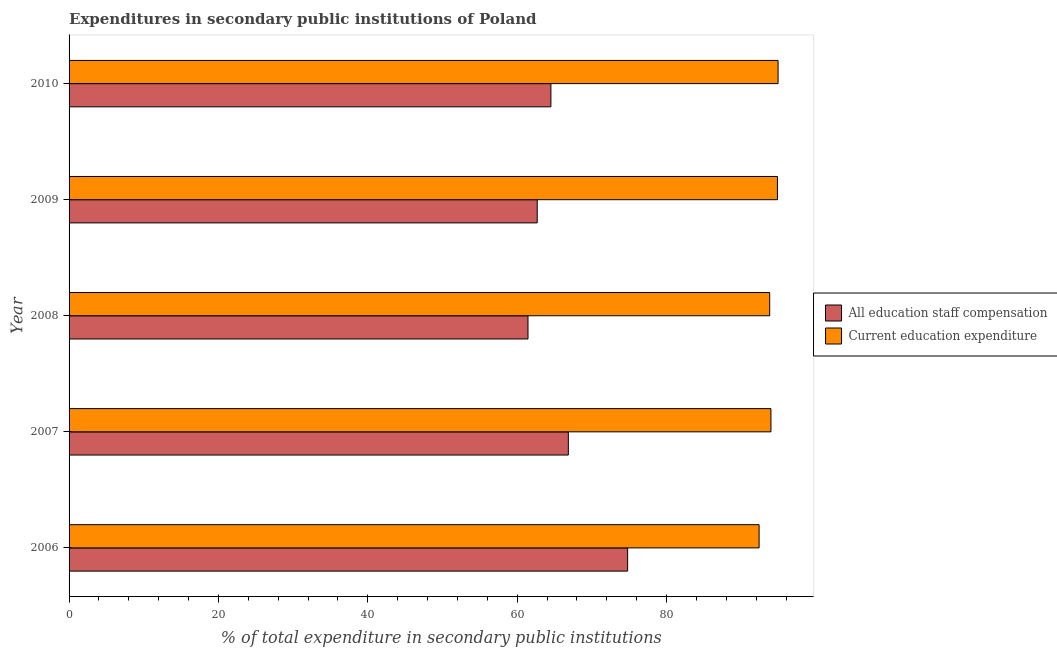Are the number of bars per tick equal to the number of legend labels?
Your answer should be compact. Yes. Are the number of bars on each tick of the Y-axis equal?
Make the answer very short. Yes. How many bars are there on the 3rd tick from the bottom?
Provide a short and direct response. 2. In how many cases, is the number of bars for a given year not equal to the number of legend labels?
Your answer should be very brief. 0. What is the expenditure in staff compensation in 2009?
Your answer should be very brief. 62.69. Across all years, what is the maximum expenditure in staff compensation?
Ensure brevity in your answer.  74.79. Across all years, what is the minimum expenditure in education?
Provide a short and direct response. 92.4. In which year was the expenditure in education maximum?
Provide a succinct answer. 2010. What is the total expenditure in education in the graph?
Offer a very short reply. 469.98. What is the difference between the expenditure in staff compensation in 2006 and that in 2010?
Offer a terse response. 10.27. What is the difference between the expenditure in education in 2008 and the expenditure in staff compensation in 2010?
Provide a succinct answer. 29.3. What is the average expenditure in staff compensation per year?
Keep it short and to the point. 66.06. In the year 2007, what is the difference between the expenditure in staff compensation and expenditure in education?
Your answer should be very brief. -27.13. In how many years, is the expenditure in staff compensation greater than 36 %?
Keep it short and to the point. 5. Is the expenditure in staff compensation in 2006 less than that in 2007?
Your response must be concise. No. What is the difference between the highest and the second highest expenditure in staff compensation?
Your answer should be very brief. 7.94. What is the difference between the highest and the lowest expenditure in education?
Your response must be concise. 2.54. What does the 2nd bar from the top in 2010 represents?
Provide a short and direct response. All education staff compensation. What does the 2nd bar from the bottom in 2008 represents?
Your response must be concise. Current education expenditure. How many bars are there?
Your response must be concise. 10. How many years are there in the graph?
Your answer should be very brief. 5. Are the values on the major ticks of X-axis written in scientific E-notation?
Give a very brief answer. No. Does the graph contain grids?
Your answer should be very brief. No. How many legend labels are there?
Provide a short and direct response. 2. What is the title of the graph?
Your answer should be very brief. Expenditures in secondary public institutions of Poland. Does "Mobile cellular" appear as one of the legend labels in the graph?
Make the answer very short. No. What is the label or title of the X-axis?
Offer a very short reply. % of total expenditure in secondary public institutions. What is the % of total expenditure in secondary public institutions of All education staff compensation in 2006?
Provide a succinct answer. 74.79. What is the % of total expenditure in secondary public institutions in Current education expenditure in 2006?
Provide a succinct answer. 92.4. What is the % of total expenditure in secondary public institutions in All education staff compensation in 2007?
Your answer should be very brief. 66.85. What is the % of total expenditure in secondary public institutions of Current education expenditure in 2007?
Offer a terse response. 93.98. What is the % of total expenditure in secondary public institutions of All education staff compensation in 2008?
Give a very brief answer. 61.45. What is the % of total expenditure in secondary public institutions in Current education expenditure in 2008?
Provide a succinct answer. 93.82. What is the % of total expenditure in secondary public institutions of All education staff compensation in 2009?
Offer a very short reply. 62.69. What is the % of total expenditure in secondary public institutions in Current education expenditure in 2009?
Your answer should be very brief. 94.85. What is the % of total expenditure in secondary public institutions of All education staff compensation in 2010?
Offer a terse response. 64.52. What is the % of total expenditure in secondary public institutions in Current education expenditure in 2010?
Keep it short and to the point. 94.94. Across all years, what is the maximum % of total expenditure in secondary public institutions in All education staff compensation?
Provide a short and direct response. 74.79. Across all years, what is the maximum % of total expenditure in secondary public institutions in Current education expenditure?
Provide a succinct answer. 94.94. Across all years, what is the minimum % of total expenditure in secondary public institutions of All education staff compensation?
Give a very brief answer. 61.45. Across all years, what is the minimum % of total expenditure in secondary public institutions of Current education expenditure?
Make the answer very short. 92.4. What is the total % of total expenditure in secondary public institutions of All education staff compensation in the graph?
Offer a very short reply. 330.3. What is the total % of total expenditure in secondary public institutions in Current education expenditure in the graph?
Your answer should be very brief. 469.98. What is the difference between the % of total expenditure in secondary public institutions of All education staff compensation in 2006 and that in 2007?
Your answer should be compact. 7.94. What is the difference between the % of total expenditure in secondary public institutions in Current education expenditure in 2006 and that in 2007?
Give a very brief answer. -1.58. What is the difference between the % of total expenditure in secondary public institutions in All education staff compensation in 2006 and that in 2008?
Ensure brevity in your answer.  13.34. What is the difference between the % of total expenditure in secondary public institutions in Current education expenditure in 2006 and that in 2008?
Offer a very short reply. -1.42. What is the difference between the % of total expenditure in secondary public institutions in All education staff compensation in 2006 and that in 2009?
Give a very brief answer. 12.1. What is the difference between the % of total expenditure in secondary public institutions of Current education expenditure in 2006 and that in 2009?
Your answer should be compact. -2.45. What is the difference between the % of total expenditure in secondary public institutions of All education staff compensation in 2006 and that in 2010?
Make the answer very short. 10.27. What is the difference between the % of total expenditure in secondary public institutions in Current education expenditure in 2006 and that in 2010?
Offer a very short reply. -2.54. What is the difference between the % of total expenditure in secondary public institutions of All education staff compensation in 2007 and that in 2008?
Provide a succinct answer. 5.4. What is the difference between the % of total expenditure in secondary public institutions in Current education expenditure in 2007 and that in 2008?
Keep it short and to the point. 0.17. What is the difference between the % of total expenditure in secondary public institutions in All education staff compensation in 2007 and that in 2009?
Provide a short and direct response. 4.17. What is the difference between the % of total expenditure in secondary public institutions of Current education expenditure in 2007 and that in 2009?
Provide a succinct answer. -0.87. What is the difference between the % of total expenditure in secondary public institutions of All education staff compensation in 2007 and that in 2010?
Give a very brief answer. 2.34. What is the difference between the % of total expenditure in secondary public institutions of Current education expenditure in 2007 and that in 2010?
Offer a terse response. -0.96. What is the difference between the % of total expenditure in secondary public institutions of All education staff compensation in 2008 and that in 2009?
Offer a terse response. -1.23. What is the difference between the % of total expenditure in secondary public institutions of Current education expenditure in 2008 and that in 2009?
Offer a terse response. -1.04. What is the difference between the % of total expenditure in secondary public institutions of All education staff compensation in 2008 and that in 2010?
Offer a very short reply. -3.07. What is the difference between the % of total expenditure in secondary public institutions of Current education expenditure in 2008 and that in 2010?
Ensure brevity in your answer.  -1.12. What is the difference between the % of total expenditure in secondary public institutions of All education staff compensation in 2009 and that in 2010?
Give a very brief answer. -1.83. What is the difference between the % of total expenditure in secondary public institutions in Current education expenditure in 2009 and that in 2010?
Make the answer very short. -0.08. What is the difference between the % of total expenditure in secondary public institutions of All education staff compensation in 2006 and the % of total expenditure in secondary public institutions of Current education expenditure in 2007?
Offer a terse response. -19.19. What is the difference between the % of total expenditure in secondary public institutions of All education staff compensation in 2006 and the % of total expenditure in secondary public institutions of Current education expenditure in 2008?
Give a very brief answer. -19.03. What is the difference between the % of total expenditure in secondary public institutions of All education staff compensation in 2006 and the % of total expenditure in secondary public institutions of Current education expenditure in 2009?
Ensure brevity in your answer.  -20.06. What is the difference between the % of total expenditure in secondary public institutions in All education staff compensation in 2006 and the % of total expenditure in secondary public institutions in Current education expenditure in 2010?
Provide a short and direct response. -20.15. What is the difference between the % of total expenditure in secondary public institutions in All education staff compensation in 2007 and the % of total expenditure in secondary public institutions in Current education expenditure in 2008?
Make the answer very short. -26.96. What is the difference between the % of total expenditure in secondary public institutions of All education staff compensation in 2007 and the % of total expenditure in secondary public institutions of Current education expenditure in 2009?
Offer a very short reply. -28. What is the difference between the % of total expenditure in secondary public institutions of All education staff compensation in 2007 and the % of total expenditure in secondary public institutions of Current education expenditure in 2010?
Ensure brevity in your answer.  -28.08. What is the difference between the % of total expenditure in secondary public institutions of All education staff compensation in 2008 and the % of total expenditure in secondary public institutions of Current education expenditure in 2009?
Make the answer very short. -33.4. What is the difference between the % of total expenditure in secondary public institutions in All education staff compensation in 2008 and the % of total expenditure in secondary public institutions in Current education expenditure in 2010?
Your answer should be very brief. -33.49. What is the difference between the % of total expenditure in secondary public institutions of All education staff compensation in 2009 and the % of total expenditure in secondary public institutions of Current education expenditure in 2010?
Make the answer very short. -32.25. What is the average % of total expenditure in secondary public institutions in All education staff compensation per year?
Offer a terse response. 66.06. What is the average % of total expenditure in secondary public institutions in Current education expenditure per year?
Provide a succinct answer. 94. In the year 2006, what is the difference between the % of total expenditure in secondary public institutions in All education staff compensation and % of total expenditure in secondary public institutions in Current education expenditure?
Give a very brief answer. -17.61. In the year 2007, what is the difference between the % of total expenditure in secondary public institutions in All education staff compensation and % of total expenditure in secondary public institutions in Current education expenditure?
Offer a terse response. -27.13. In the year 2008, what is the difference between the % of total expenditure in secondary public institutions of All education staff compensation and % of total expenditure in secondary public institutions of Current education expenditure?
Give a very brief answer. -32.37. In the year 2009, what is the difference between the % of total expenditure in secondary public institutions of All education staff compensation and % of total expenditure in secondary public institutions of Current education expenditure?
Offer a very short reply. -32.17. In the year 2010, what is the difference between the % of total expenditure in secondary public institutions in All education staff compensation and % of total expenditure in secondary public institutions in Current education expenditure?
Your response must be concise. -30.42. What is the ratio of the % of total expenditure in secondary public institutions in All education staff compensation in 2006 to that in 2007?
Ensure brevity in your answer.  1.12. What is the ratio of the % of total expenditure in secondary public institutions of Current education expenditure in 2006 to that in 2007?
Keep it short and to the point. 0.98. What is the ratio of the % of total expenditure in secondary public institutions of All education staff compensation in 2006 to that in 2008?
Give a very brief answer. 1.22. What is the ratio of the % of total expenditure in secondary public institutions of Current education expenditure in 2006 to that in 2008?
Your answer should be very brief. 0.98. What is the ratio of the % of total expenditure in secondary public institutions of All education staff compensation in 2006 to that in 2009?
Your answer should be very brief. 1.19. What is the ratio of the % of total expenditure in secondary public institutions of Current education expenditure in 2006 to that in 2009?
Your response must be concise. 0.97. What is the ratio of the % of total expenditure in secondary public institutions in All education staff compensation in 2006 to that in 2010?
Keep it short and to the point. 1.16. What is the ratio of the % of total expenditure in secondary public institutions of Current education expenditure in 2006 to that in 2010?
Offer a very short reply. 0.97. What is the ratio of the % of total expenditure in secondary public institutions in All education staff compensation in 2007 to that in 2008?
Give a very brief answer. 1.09. What is the ratio of the % of total expenditure in secondary public institutions of Current education expenditure in 2007 to that in 2008?
Offer a very short reply. 1. What is the ratio of the % of total expenditure in secondary public institutions of All education staff compensation in 2007 to that in 2009?
Your response must be concise. 1.07. What is the ratio of the % of total expenditure in secondary public institutions in Current education expenditure in 2007 to that in 2009?
Provide a short and direct response. 0.99. What is the ratio of the % of total expenditure in secondary public institutions of All education staff compensation in 2007 to that in 2010?
Make the answer very short. 1.04. What is the ratio of the % of total expenditure in secondary public institutions in All education staff compensation in 2008 to that in 2009?
Your response must be concise. 0.98. What is the ratio of the % of total expenditure in secondary public institutions of All education staff compensation in 2008 to that in 2010?
Make the answer very short. 0.95. What is the ratio of the % of total expenditure in secondary public institutions of All education staff compensation in 2009 to that in 2010?
Your answer should be compact. 0.97. What is the ratio of the % of total expenditure in secondary public institutions of Current education expenditure in 2009 to that in 2010?
Offer a very short reply. 1. What is the difference between the highest and the second highest % of total expenditure in secondary public institutions of All education staff compensation?
Your response must be concise. 7.94. What is the difference between the highest and the second highest % of total expenditure in secondary public institutions in Current education expenditure?
Your response must be concise. 0.08. What is the difference between the highest and the lowest % of total expenditure in secondary public institutions in All education staff compensation?
Make the answer very short. 13.34. What is the difference between the highest and the lowest % of total expenditure in secondary public institutions of Current education expenditure?
Make the answer very short. 2.54. 